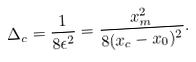Convert formula to latex. <formula><loc_0><loc_0><loc_500><loc_500>\Delta _ { c } = \frac { 1 } { 8 \epsilon ^ { 2 } } = \frac { x _ { m } ^ { 2 } } { 8 ( x _ { c } - x _ { 0 } ) ^ { 2 } } .</formula> 